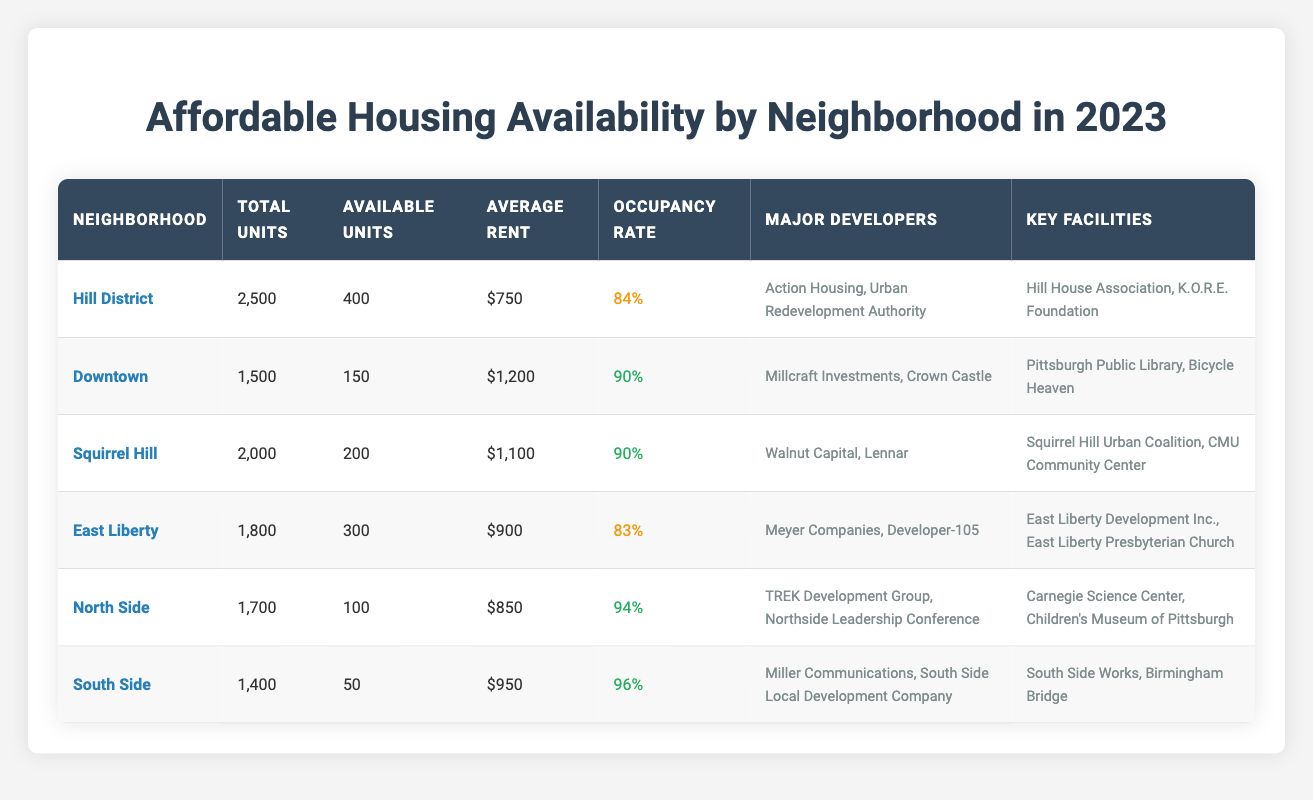What neighborhood has the highest number of available units? In the table, the Hill District is listed with 400 available units, which is higher than any other neighborhood's available units. The next highest is East Liberty with 300 available units.
Answer: Hill District What is the average rent for units in East Liberty? The table specifically lists the average rent for East Liberty as $900.
Answer: $900 Which neighborhood has the lowest occupancy rate? The Hill District has an occupancy rate of 84%, making it the neighborhood with the lowest occupancy rate compared to East Liberty's 83% and South Side's 96%.
Answer: Hill District How many total units are there in South Side? The table indicates that the South Side has a total of 1,400 units.
Answer: 1,400 What is the difference in average rent between Downtown and North Side? The average rent in Downtown is $1,200 and in North Side is $850. The difference is calculated as $1,200 - $850 = $350.
Answer: $350 Is the occupancy rate in the South Side higher than in the Hill District? The table shows that South Side has an occupancy rate of 96%, while Hill District has an occupancy rate of 84%. Since 96% > 84%, the statement is true.
Answer: Yes Which neighborhood has the highest occupancy rate? According to the table, South Side has the highest occupancy rate at 96%, followed closely by North Side at 94%.
Answer: South Side If we combine the available units in East Liberty and Squirrel Hill, how many units are available? East Liberty has 300 available units and Squirrel Hill has 200 available units. Thus, the total is 300 + 200 = 500 available units.
Answer: 500 What is the total number of affordable housing units across all neighborhoods listed? The total units can be calculated by summing up all total units: 2500 (Hill District) + 1500 (Downtown) + 2000 (Squirrel Hill) + 1800 (East Liberty) + 1700 (North Side) + 1400 (South Side) = 10900 units.
Answer: 10,900 Which major developers are involved in affordable housing in the Hill District? The table lists Action Housing and Urban Redevelopment Authority as the major developers for the Hill District.
Answer: Action Housing, Urban Redevelopment Authority 